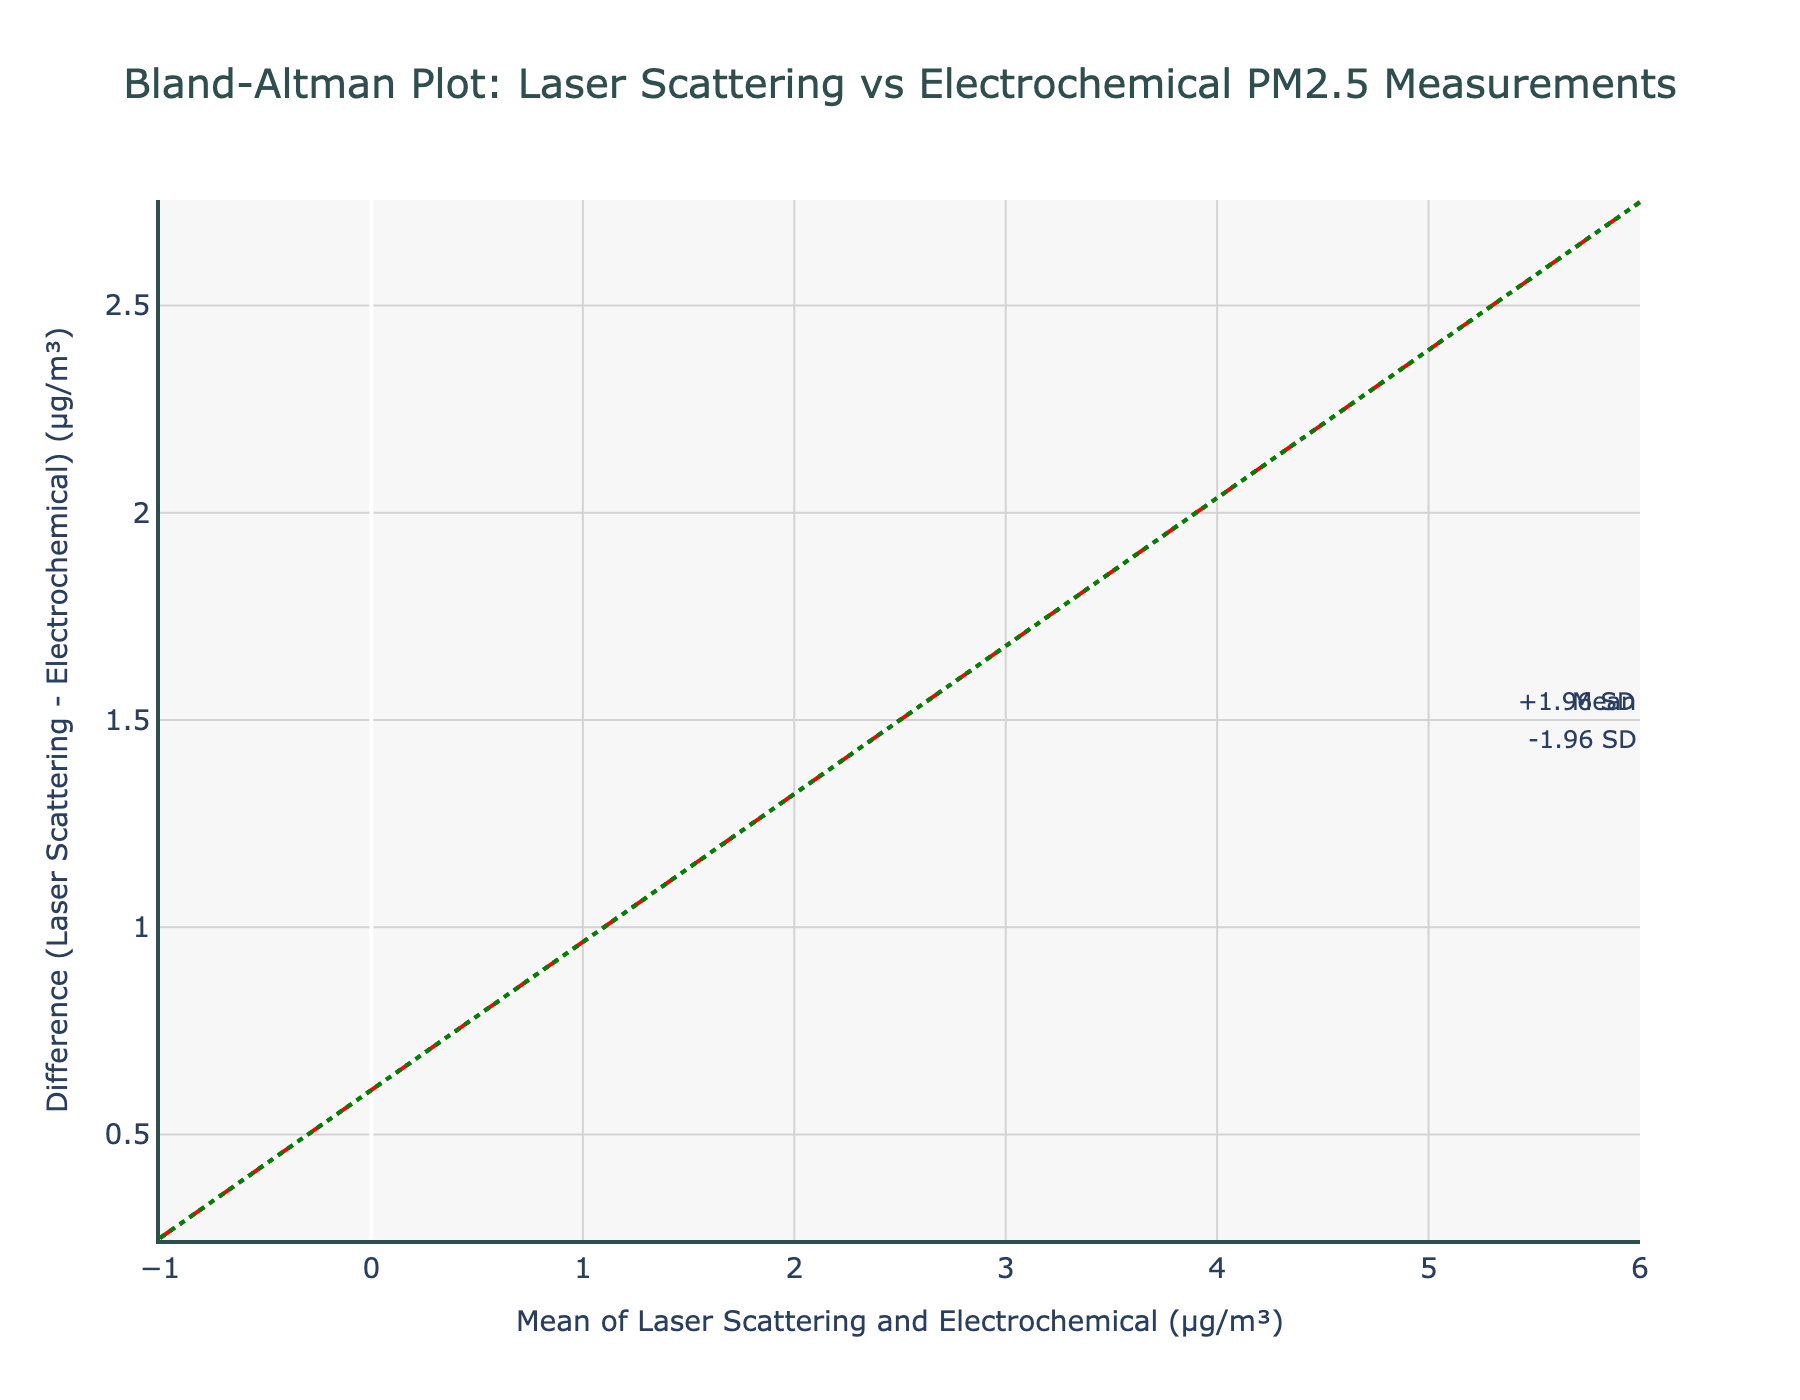What's the title of the Bland-Altman plot? The title is usually written at the top of the plot, which in this case is "Bland-Altman Plot: Laser Scattering vs Electrochemical PM2.5 Measurements".
Answer: Bland-Altman Plot: Laser Scattering vs Electrochemical PM2.5 Measurements Which color is used for the markers in the scatter plot? By observing the color of the markers on the plot, they appear to be teal with a dark outline, which is described as 'color='rgba(0, 128, 128, 0.7)'' in natural language.
Answer: Teal with a dark outline How is the mean difference illustrated on the plot? The mean difference is shown as a horizontal red dashed line, which is also annotated with the word "Mean" on the plot.
Answer: Red dashed line What do the green dotted lines represent? These lines represent the limits of agreement, defined as mean ± 1.96 standard deviations (SD), and are annotated as "+1.96 SD" and "-1.96 SD".
Answer: Limits of agreement What can you infer if a data point lies beyond the green dotted lines? If a data point lies beyond the green dotted lines, it indicates that the difference between the two measurement methods for that point is greater than would typically be expected based on the range set by ±1.96 SD.
Answer: Greater difference than expected How many data points are there on the plot? By counting the number of markers on the plot, you can see there are six data points.
Answer: Six What's the mean difference between the laser scattering and electrochemical measurements? The mean difference is shown by the red dashed line annotated as "Mean". The y-value of this line represents the mean difference.
Answer: The specific value would need to be calculated manually from the data provided Why would some of the points be above the mean line while others are below it? Points above the mean line indicate that the laser scattering measurements are higher than the electrochemical measurements for those points, while points below the mean line indicate the opposite.
Answer: Differences in measurement values How do you calculate the mean of the two methods for each data point? For each pair of measurements, you add the laser scattering value and the electrochemical value, then divide by 2.
Answer: (Laser + Electrochemical) / 2 What could be a potential reason for variance between the two sensor types shown in the plot? Variance can be due to inherent differences in sensor technology, calibration issues, or environmental factors affecting the sensors differently.
Answer: Differences in technology or calibration 